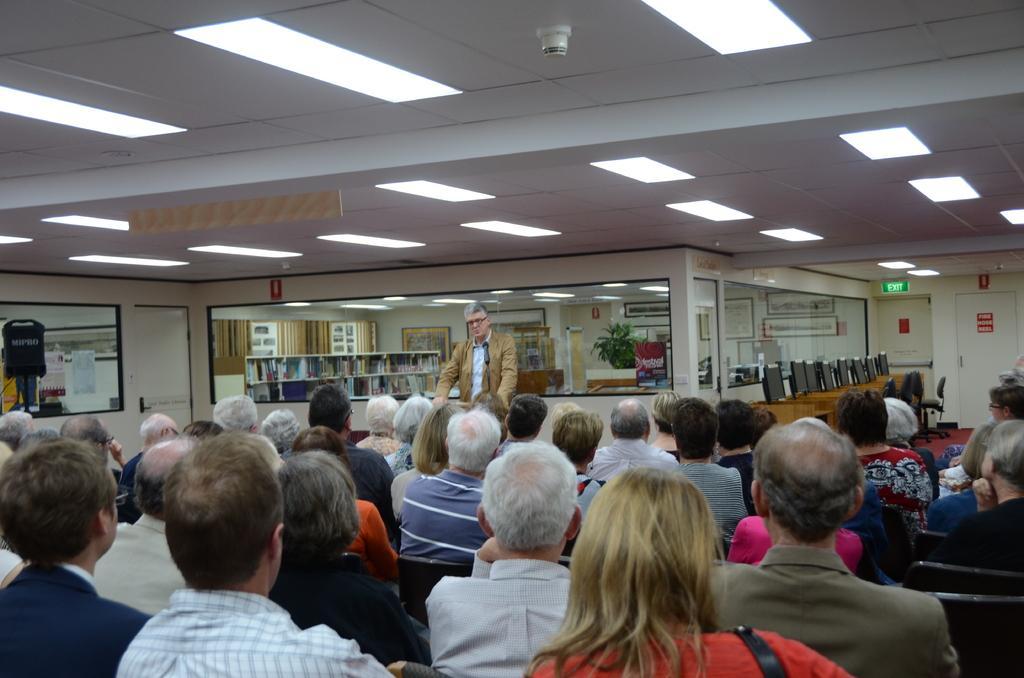Could you give a brief overview of what you see in this image? In this image there is a hall, in that all people are sitting on chairs, in front of the people there is a man standing, in the background there is a wall to that wall there is a glass, at the top there is a ceiling and lights. 